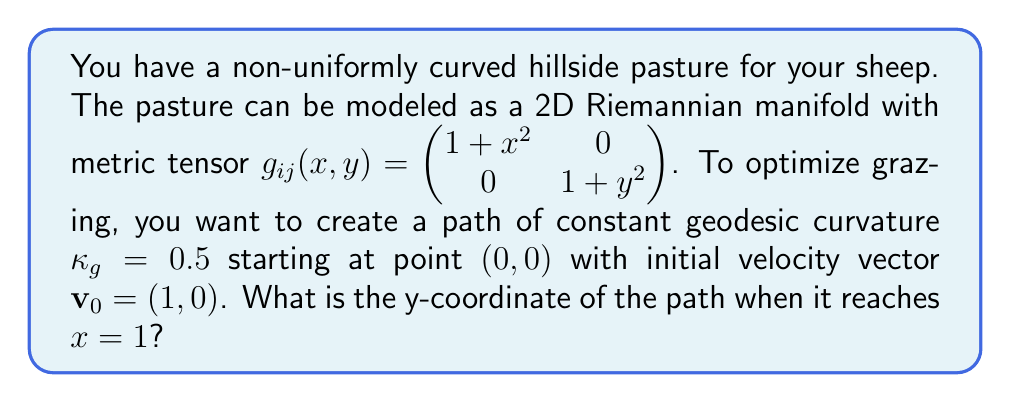Show me your answer to this math problem. Let's approach this step-by-step:

1) The geodesic curvature $\kappa_g$ is given by:

   $$\kappa_g = \frac{1}{\sqrt{g_{11}\dot{x}^2 + g_{22}\dot{y}^2}}\left(\frac{d^2y}{dx^2} + \Gamma^2_{11}\left(\frac{dy}{dx}\right)^2 - 2\Gamma^2_{12}\frac{dy}{dx} - \Gamma^1_{11}\right)$$

   where $\Gamma^i_{jk}$ are the Christoffel symbols.

2) Calculate the Christoffel symbols:
   
   $$\Gamma^1_{11} = \frac{x}{1+x^2}, \Gamma^2_{22} = \frac{y}{1+y^2}, \Gamma^2_{12} = \Gamma^2_{21} = 0$$

3) Substitute into the geodesic curvature equation:

   $$0.5 = \frac{1}{\sqrt{(1+x^2)(1+(\frac{dy}{dx})^2)}}\left(\frac{d^2y}{dx^2} + \frac{y}{1+y^2}\left(\frac{dy}{dx}\right)^2 - \frac{x}{1+x^2}\right)$$

4) This is a complex second-order differential equation. We can simplify it by assuming $y$ is small, so $y^2 \approx 0$:

   $$0.5 = \frac{1}{\sqrt{1+x^2}}\left(\frac{d^2y}{dx^2} - \frac{x}{1+x^2}\right)$$

5) Solve this differential equation with initial conditions $y(0)=0$ and $y'(0)=0$:

   $$\frac{d^2y}{dx^2} = 0.5\sqrt{1+x^2} + \frac{x}{1+x^2}$$

6) Integrate twice:

   $$y'(x) = 0.5(\sqrt{1+x^2} - 1) + \ln(1+x^2)$$
   
   $$y(x) = 0.5(x\sqrt{1+x^2} - x - \arcsinh(x)) + x\ln(1+x^2) - 2x$$

7) Evaluate at $x=1$:

   $$y(1) = 0.5(\sqrt{2} - 1 - \arcsinh(1)) + \ln(2) - 2 \approx 0.1947$$
Answer: $y \approx 0.1947$ 